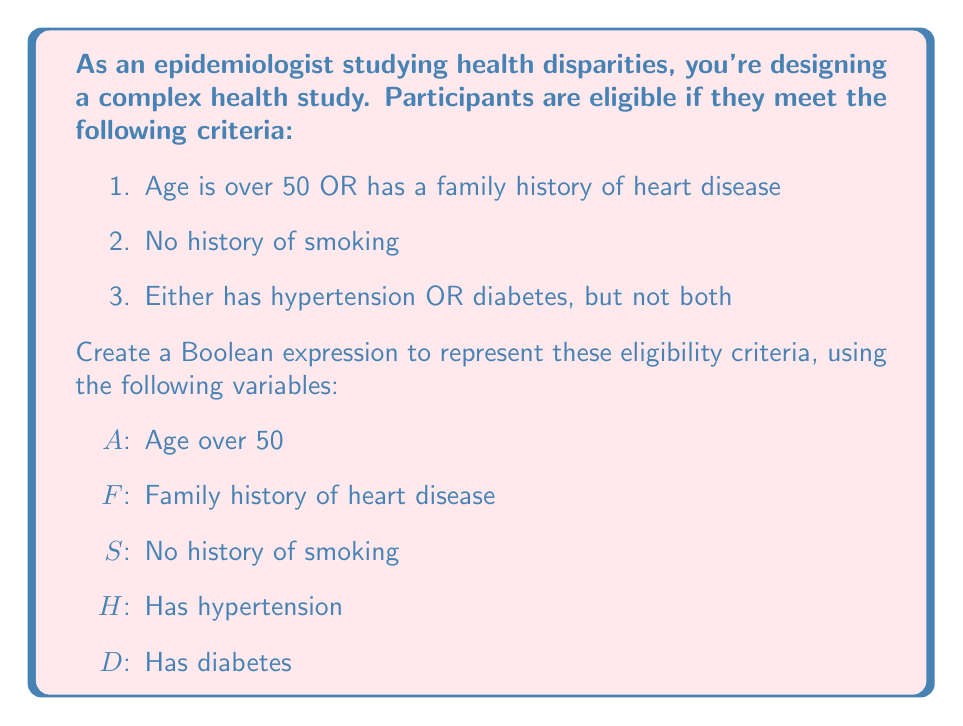Teach me how to tackle this problem. Let's break down the eligibility criteria and construct the Boolean expression step by step:

1. Age is over 50 OR has a family history of heart disease:
   This can be represented as: $(A \lor F)$

2. No history of smoking:
   This is simply represented as: $S$

3. Either has hypertension OR diabetes, but not both:
   This is an exclusive OR (XOR) operation, which can be represented as:
   $(H \lor D) \land \lnot(H \land D)$

Now, we need to combine these conditions using the AND operator, as all conditions must be met for eligibility:

$$(A \lor F) \land S \land [(H \lor D) \land \lnot(H \land D)]$$

This expression can be further simplified using the distributive property and De Morgan's laws:

$$(A \lor F) \land S \land (H \oplus D)$$

Where $\oplus$ represents the XOR operation.
Answer: $(A \lor F) \land S \land (H \oplus D)$ 